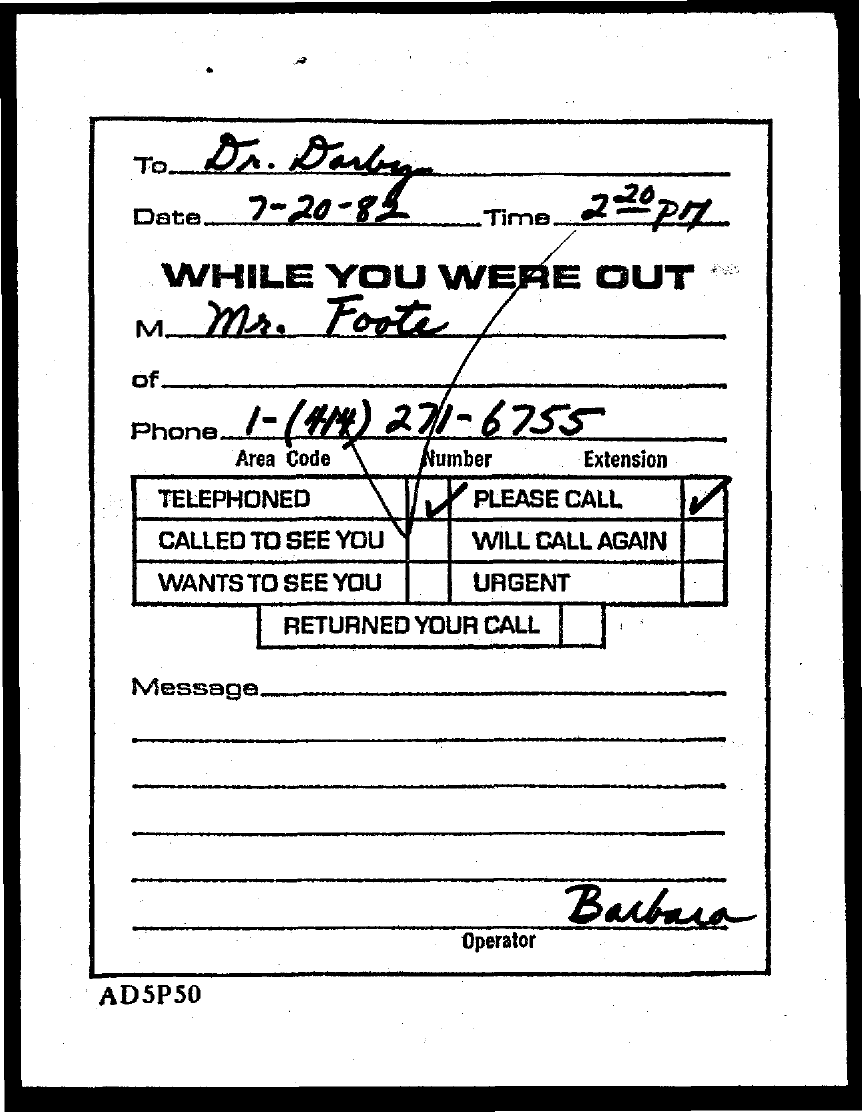What is the Phone number?
Provide a short and direct response. 1-(414) 271-6755. What is the date mentioned in the document?
Your response must be concise. 7-20-82. 